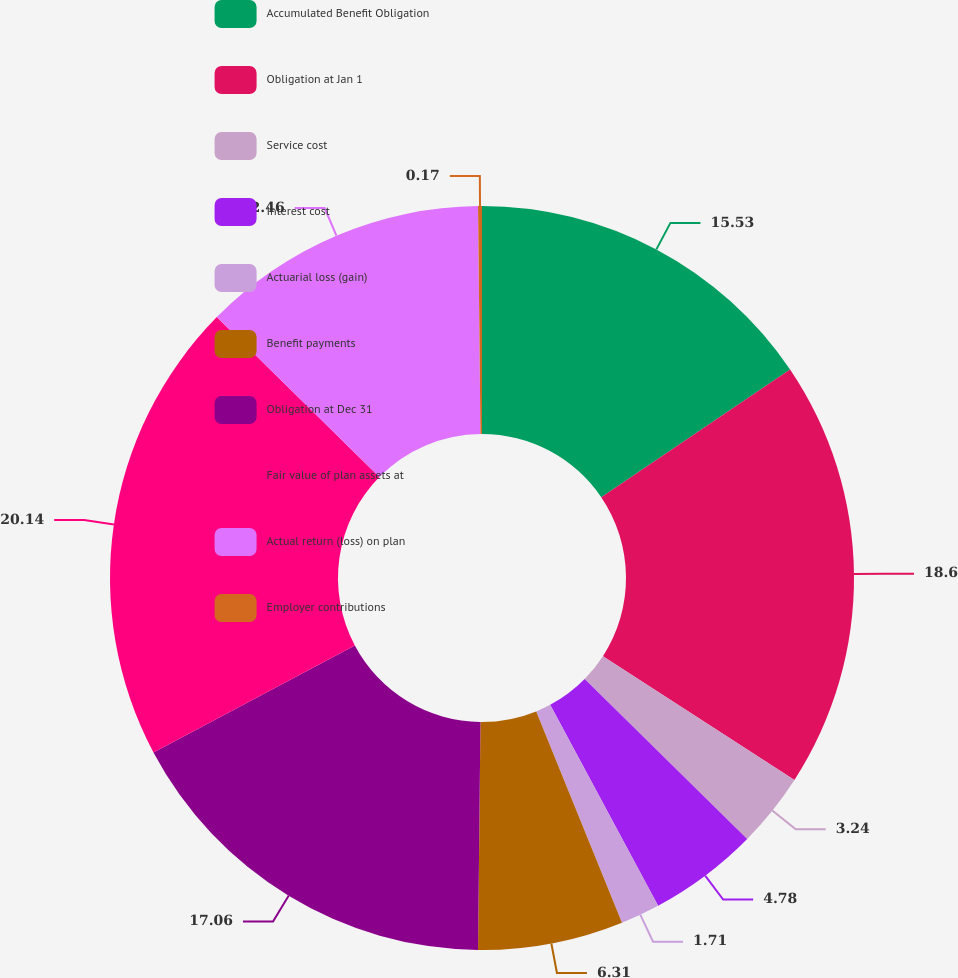Convert chart to OTSL. <chart><loc_0><loc_0><loc_500><loc_500><pie_chart><fcel>Accumulated Benefit Obligation<fcel>Obligation at Jan 1<fcel>Service cost<fcel>Interest cost<fcel>Actuarial loss (gain)<fcel>Benefit payments<fcel>Obligation at Dec 31<fcel>Fair value of plan assets at<fcel>Actual return (loss) on plan<fcel>Employer contributions<nl><fcel>15.53%<fcel>18.6%<fcel>3.24%<fcel>4.78%<fcel>1.71%<fcel>6.31%<fcel>17.06%<fcel>20.14%<fcel>12.46%<fcel>0.17%<nl></chart> 